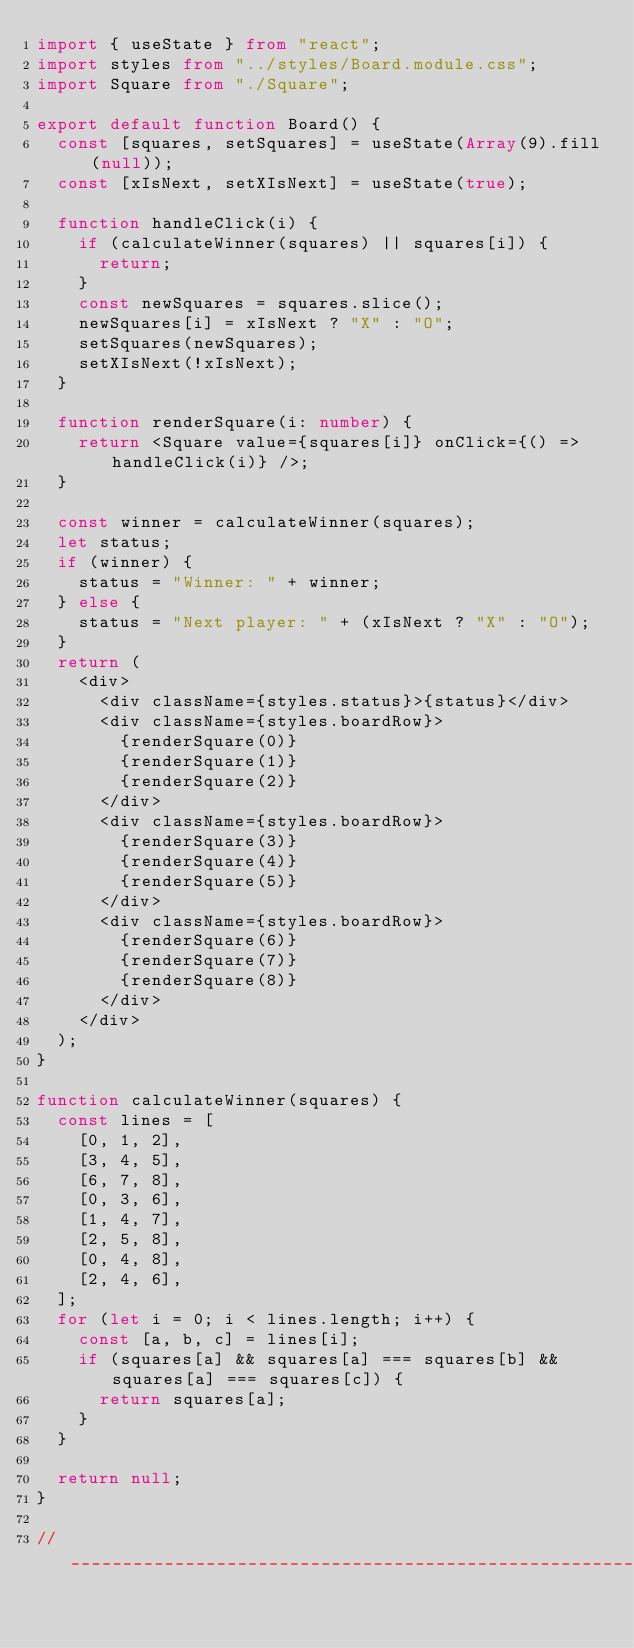Convert code to text. <code><loc_0><loc_0><loc_500><loc_500><_TypeScript_>import { useState } from "react";
import styles from "../styles/Board.module.css";
import Square from "./Square";

export default function Board() {
  const [squares, setSquares] = useState(Array(9).fill(null));
  const [xIsNext, setXIsNext] = useState(true);

  function handleClick(i) {
    if (calculateWinner(squares) || squares[i]) {
      return;
    }
    const newSquares = squares.slice();
    newSquares[i] = xIsNext ? "X" : "O";
    setSquares(newSquares);
    setXIsNext(!xIsNext);
  }

  function renderSquare(i: number) {
    return <Square value={squares[i]} onClick={() => handleClick(i)} />;
  }

  const winner = calculateWinner(squares);
  let status;
  if (winner) {
    status = "Winner: " + winner;
  } else {
    status = "Next player: " + (xIsNext ? "X" : "O");
  }
  return (
    <div>
      <div className={styles.status}>{status}</div>
      <div className={styles.boardRow}>
        {renderSquare(0)}
        {renderSquare(1)}
        {renderSquare(2)}
      </div>
      <div className={styles.boardRow}>
        {renderSquare(3)}
        {renderSquare(4)}
        {renderSquare(5)}
      </div>
      <div className={styles.boardRow}>
        {renderSquare(6)}
        {renderSquare(7)}
        {renderSquare(8)}
      </div>
    </div>
  );
}

function calculateWinner(squares) {
  const lines = [
    [0, 1, 2],
    [3, 4, 5],
    [6, 7, 8],
    [0, 3, 6],
    [1, 4, 7],
    [2, 5, 8],
    [0, 4, 8],
    [2, 4, 6],
  ];
  for (let i = 0; i < lines.length; i++) {
    const [a, b, c] = lines[i];
    if (squares[a] && squares[a] === squares[b] && squares[a] === squares[c]) {
      return squares[a];
    }
  }

  return null;
}

//_________________________________________________________________________________
</code> 